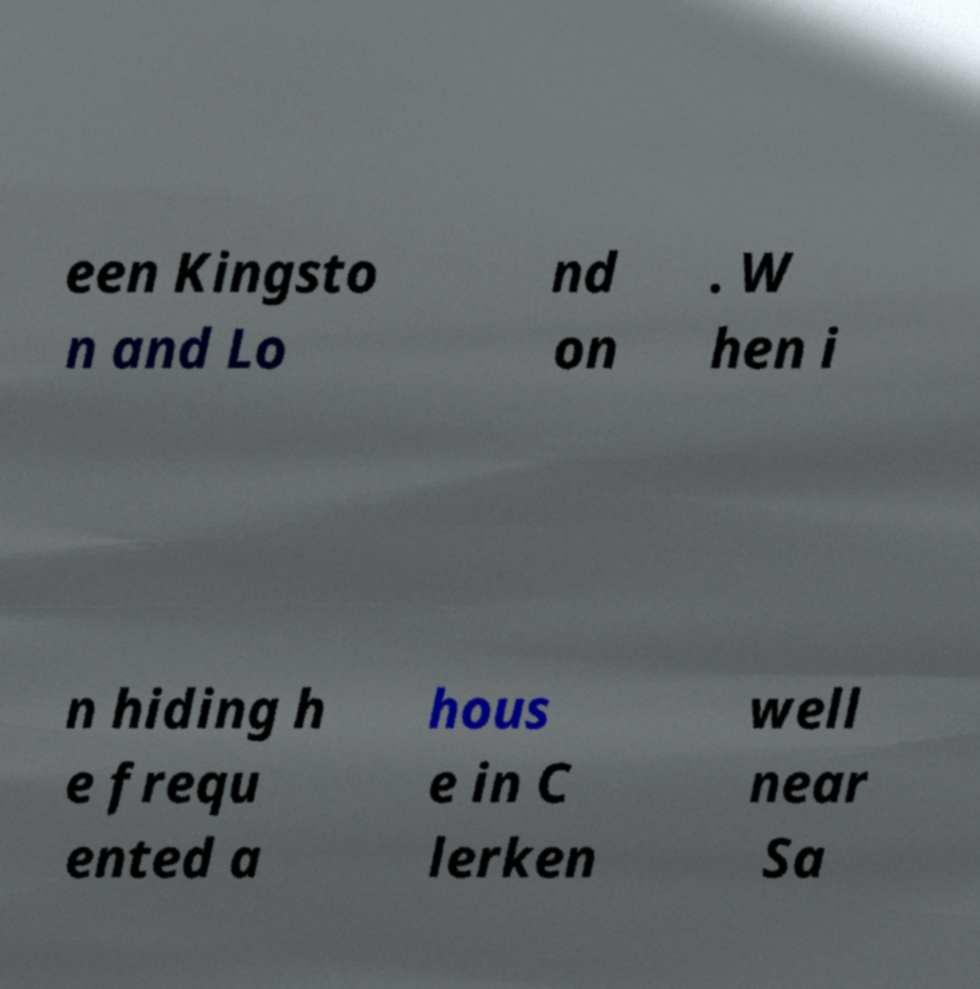Can you accurately transcribe the text from the provided image for me? een Kingsto n and Lo nd on . W hen i n hiding h e frequ ented a hous e in C lerken well near Sa 